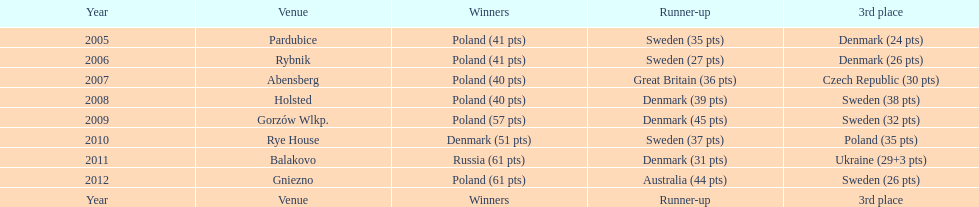In which most recent year did the 3rd place finisher score less than 25 points? 2005. 